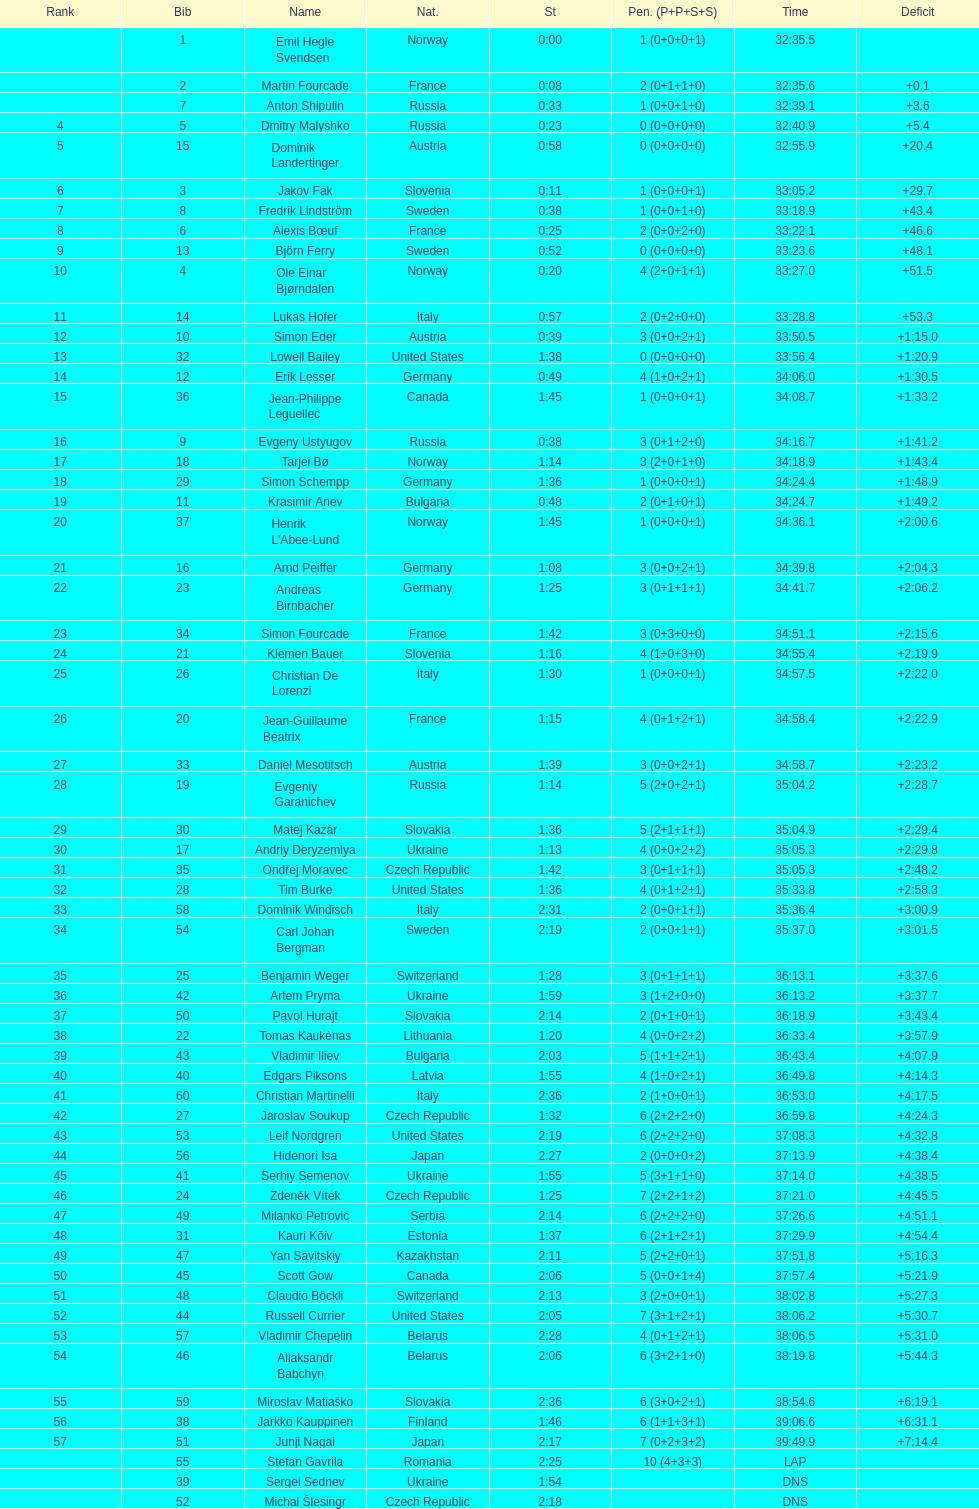What is the total number of participants between norway and france? 7. 